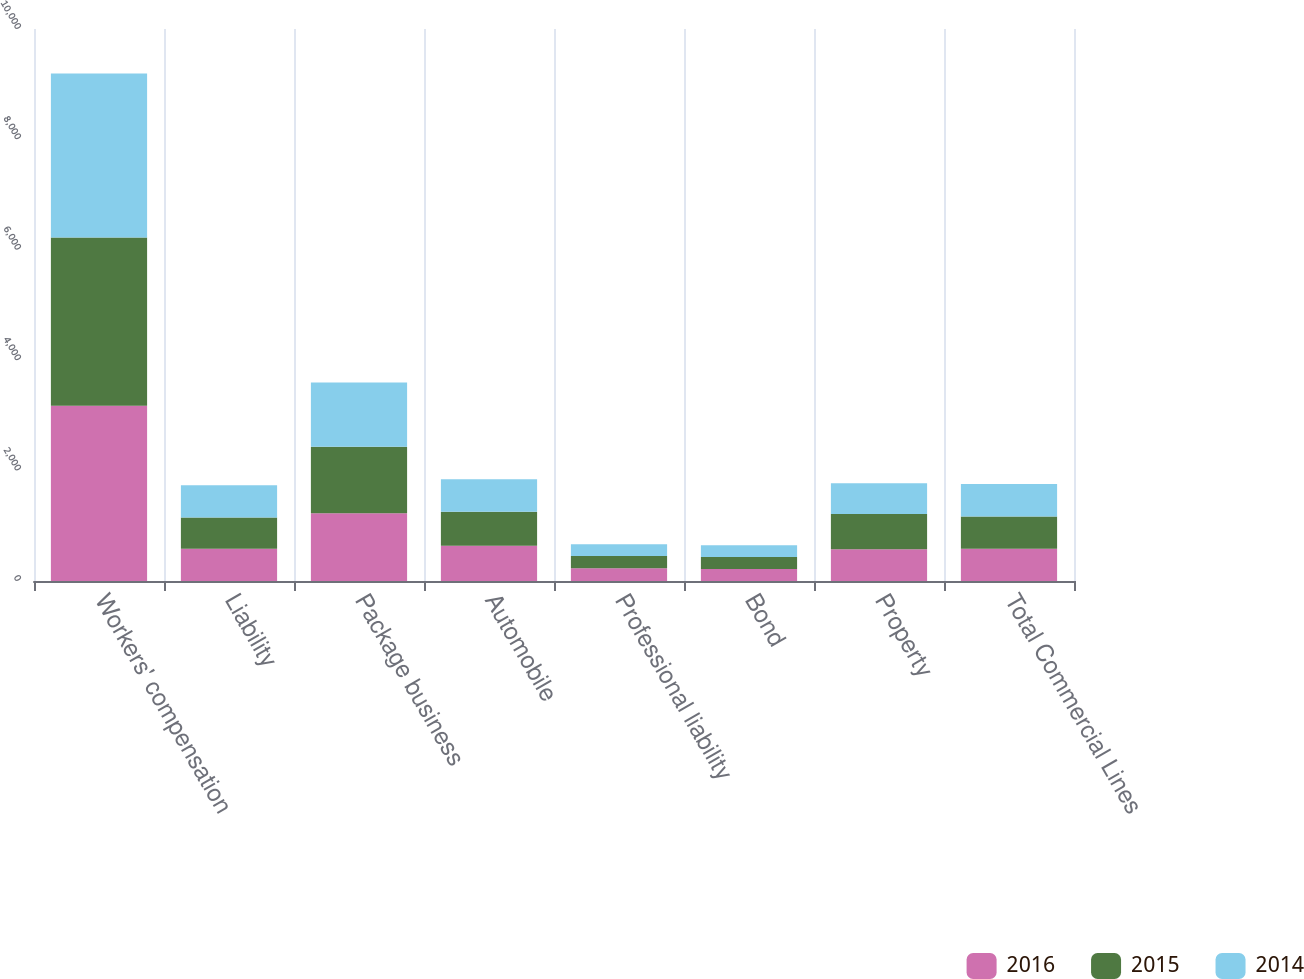<chart> <loc_0><loc_0><loc_500><loc_500><stacked_bar_chart><ecel><fcel>Workers' compensation<fcel>Liability<fcel>Package business<fcel>Automobile<fcel>Professional liability<fcel>Bond<fcel>Property<fcel>Total Commercial Lines<nl><fcel>2016<fcel>3174<fcel>585<fcel>1229<fcel>640<fcel>230<fcel>218<fcel>575<fcel>585<nl><fcel>2015<fcel>3051<fcel>567<fcel>1203<fcel>614<fcel>221<fcel>218<fcel>637<fcel>585<nl><fcel>2014<fcel>2971<fcel>582<fcel>1163<fcel>591<fcel>213<fcel>210<fcel>559<fcel>585<nl></chart> 